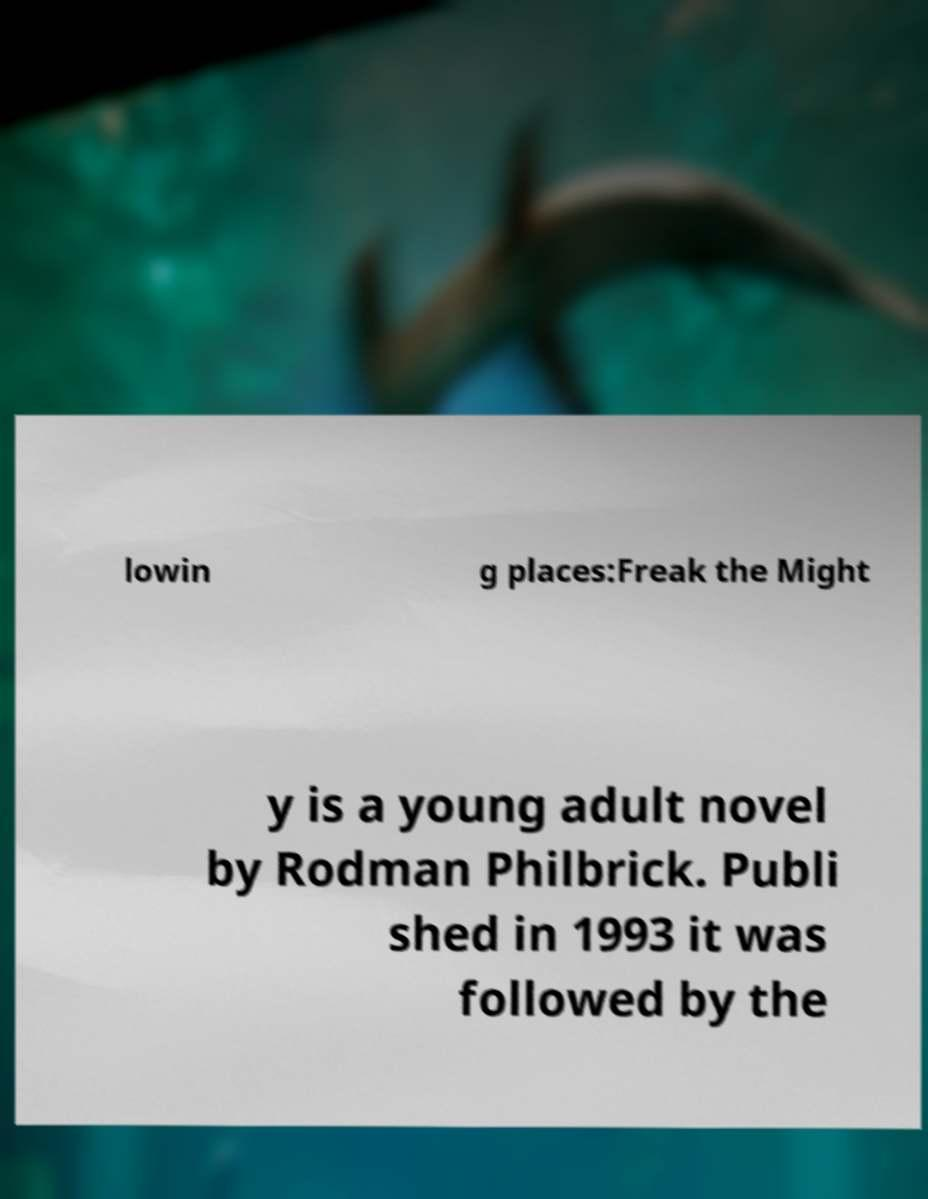What messages or text are displayed in this image? I need them in a readable, typed format. lowin g places:Freak the Might y is a young adult novel by Rodman Philbrick. Publi shed in 1993 it was followed by the 